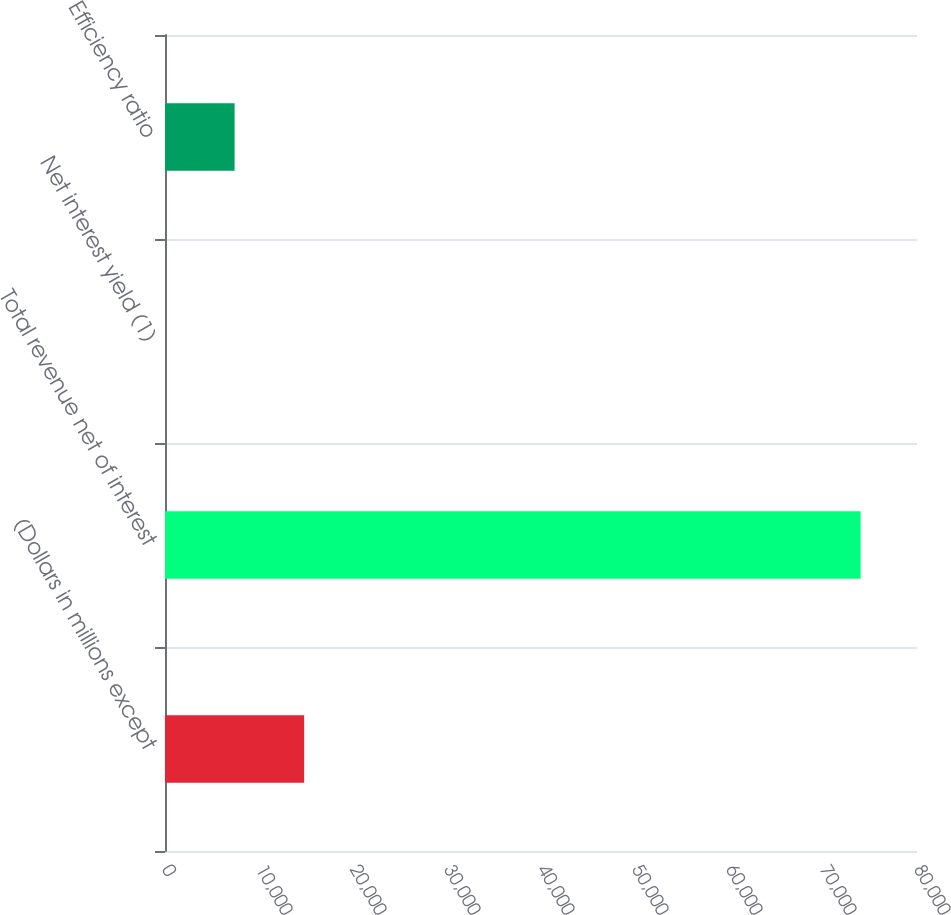Convert chart. <chart><loc_0><loc_0><loc_500><loc_500><bar_chart><fcel>(Dollars in millions except<fcel>Total revenue net of interest<fcel>Net interest yield (1)<fcel>Efficiency ratio<nl><fcel>14802.3<fcel>74000<fcel>2.82<fcel>7402.54<nl></chart> 